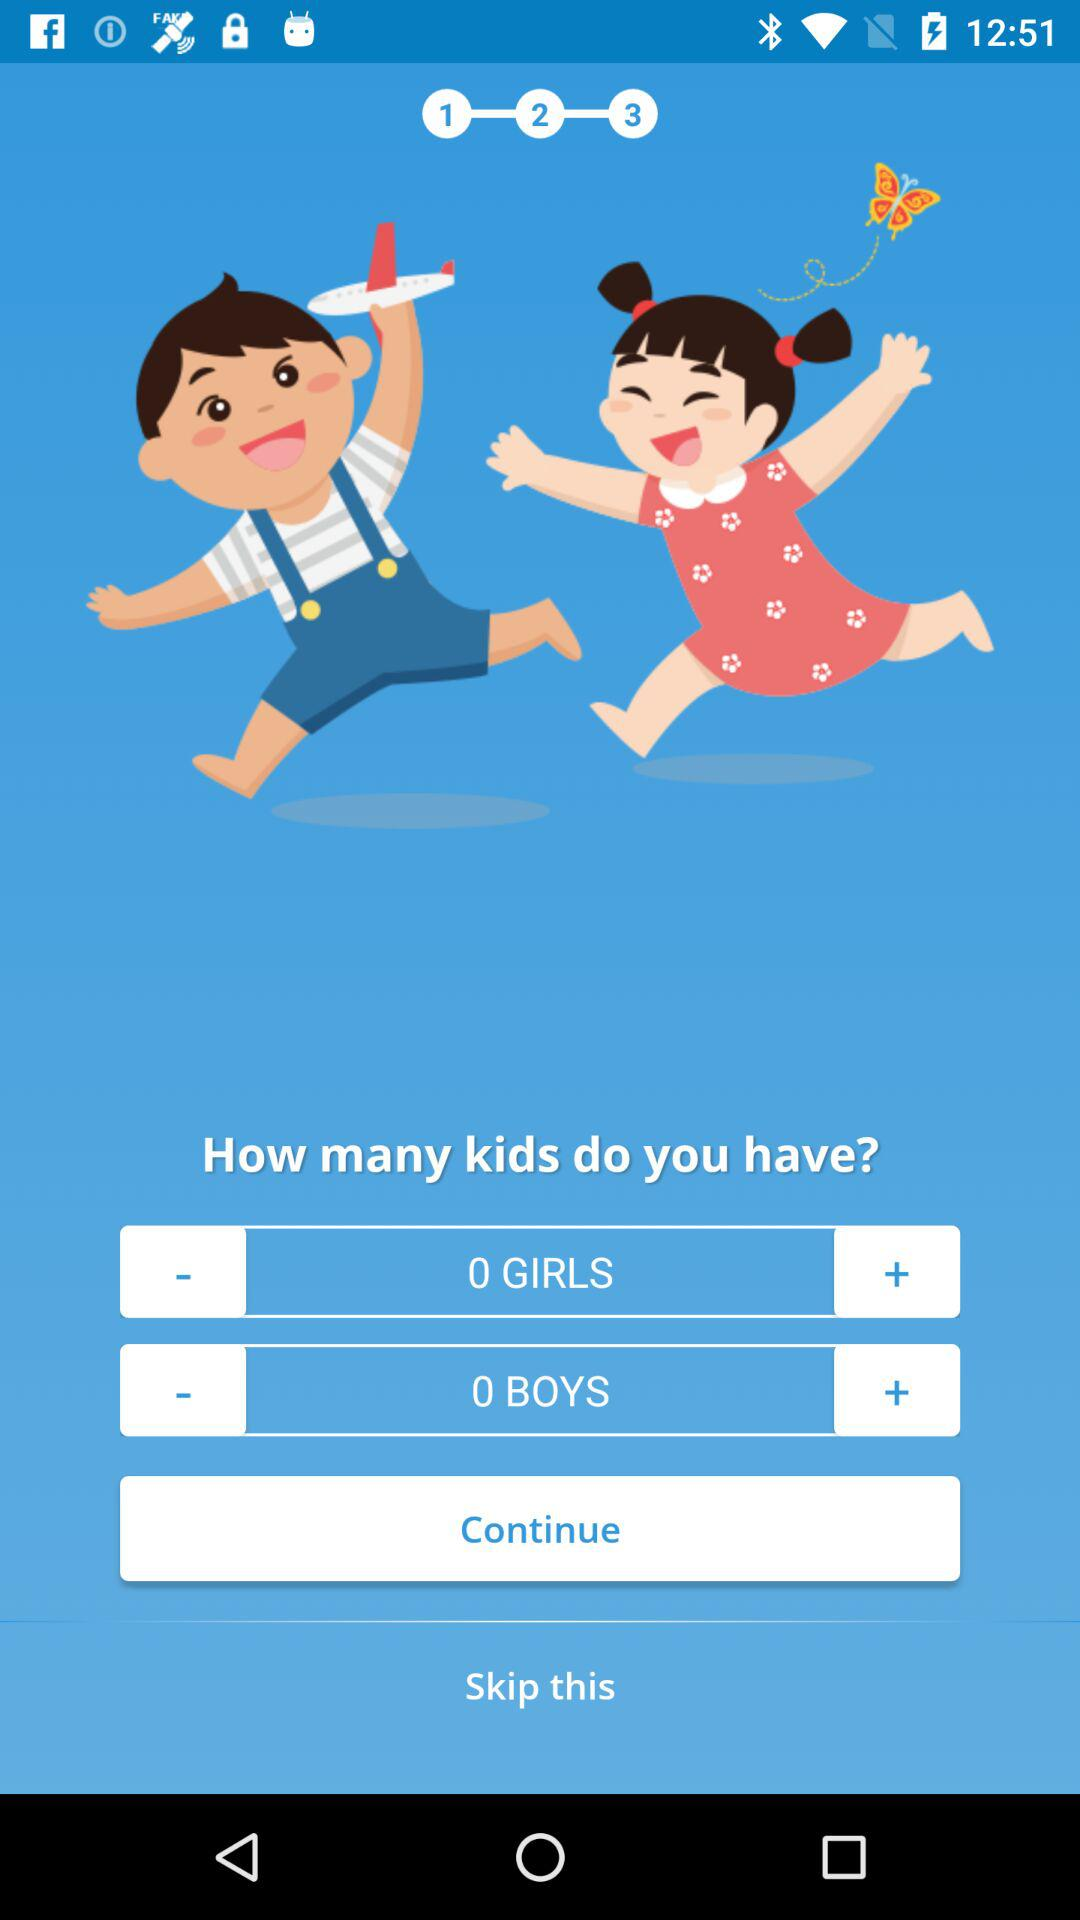How many girl children do you have? You have 0 girl children. 